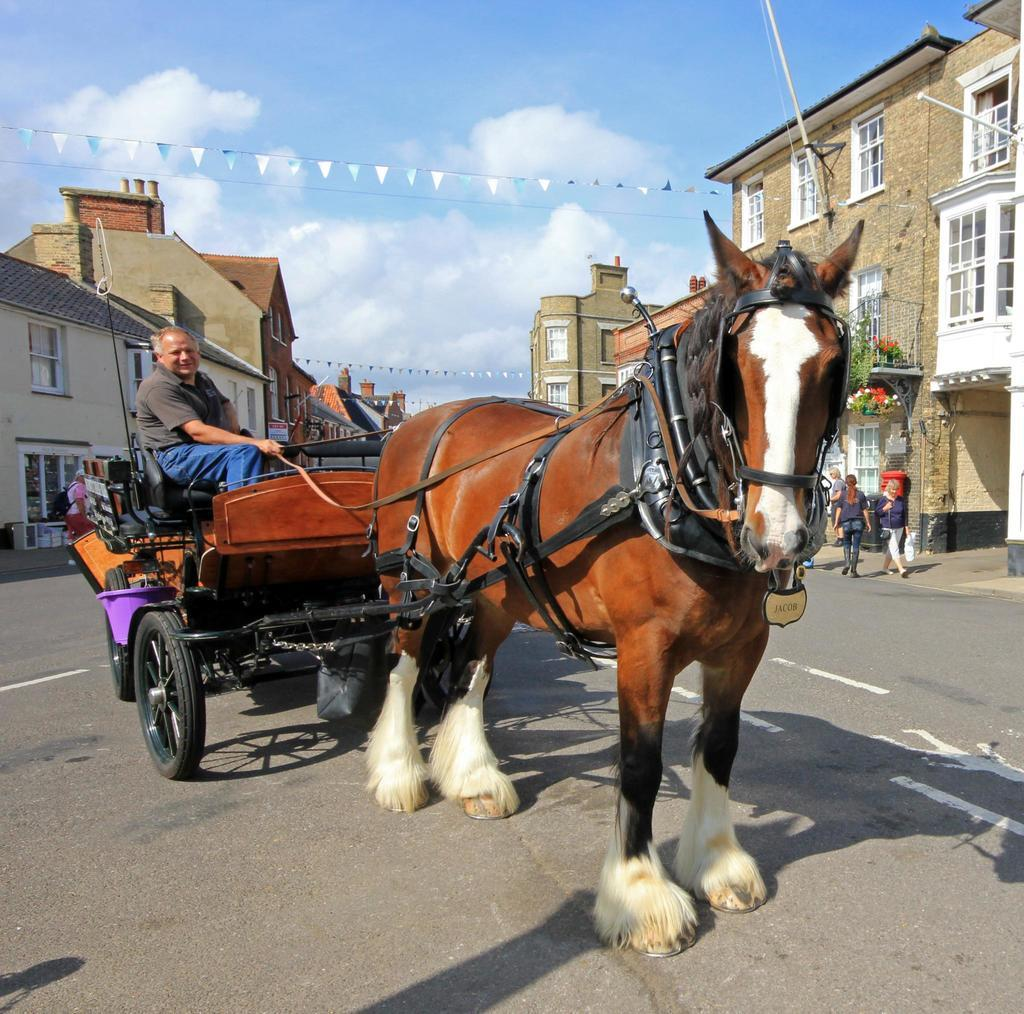What mode of transportation is featured in the image? There is a horse cart on a road in the image. Who is using the horse cart? A man is sitting in the horse cart. What can be seen on both sides of the road? There are houses on either side of the road. What color is the sky in the background of the image? The sky is blue in the background of the image. Can you tell me how many aunts are standing near the horse cart in the image? There are no aunts present in the image; only a man is sitting in the horse cart. What type of coat is the horse wearing in the image? There is no coat visible on the horse in the image. 